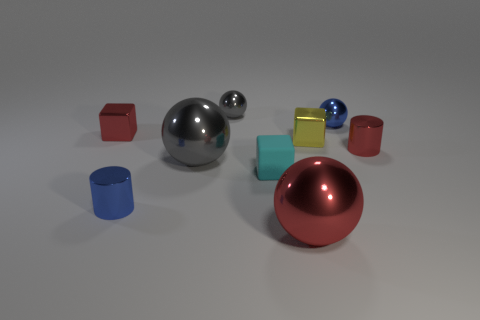What material is the thing that is in front of the matte object and to the right of the cyan matte block?
Offer a terse response. Metal. The rubber thing is what color?
Keep it short and to the point. Cyan. What number of other things are there of the same shape as the tiny gray shiny thing?
Your answer should be compact. 3. Is the number of red cubes that are right of the red shiny cylinder the same as the number of small shiny spheres that are to the left of the tiny yellow metal object?
Your response must be concise. No. What material is the tiny yellow thing?
Offer a very short reply. Metal. There is a small red object to the left of the big red ball; what is it made of?
Offer a terse response. Metal. Is there anything else that has the same material as the blue cylinder?
Provide a succinct answer. Yes. Are there more tiny red shiny cylinders to the right of the red shiny cylinder than yellow things?
Your answer should be compact. No. Are there any tiny red things that are right of the small cylinder that is to the right of the tiny blue object that is in front of the red block?
Keep it short and to the point. No. Are there any blue metal cylinders in front of the tiny gray metal sphere?
Ensure brevity in your answer.  Yes. 